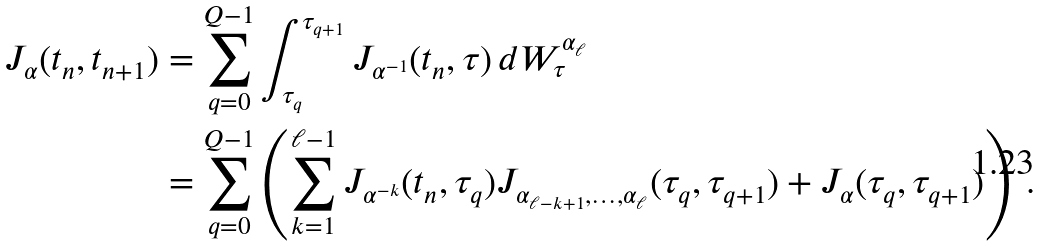<formula> <loc_0><loc_0><loc_500><loc_500>J _ { \alpha } ( t _ { n } , t _ { n + 1 } ) & = \sum _ { q = 0 } ^ { Q - 1 } \int _ { \tau _ { q } } ^ { \tau _ { q + 1 } } J _ { \alpha ^ { - 1 } } ( t _ { n } , \tau ) \, d W _ { \tau } ^ { \alpha _ { \ell } } \\ & = \sum _ { q = 0 } ^ { Q - 1 } \left ( \sum _ { k = 1 } ^ { \ell - 1 } J _ { \alpha ^ { - k } } ( t _ { n } , \tau _ { q } ) J _ { \alpha _ { \ell - k + 1 } , \dots , \alpha _ { \ell } } ( \tau _ { q } , \tau _ { q + 1 } ) + J _ { \alpha } ( \tau _ { q } , \tau _ { q + 1 } ) \right ) \, .</formula> 